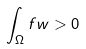<formula> <loc_0><loc_0><loc_500><loc_500>\int _ { \Omega } f w > 0</formula> 